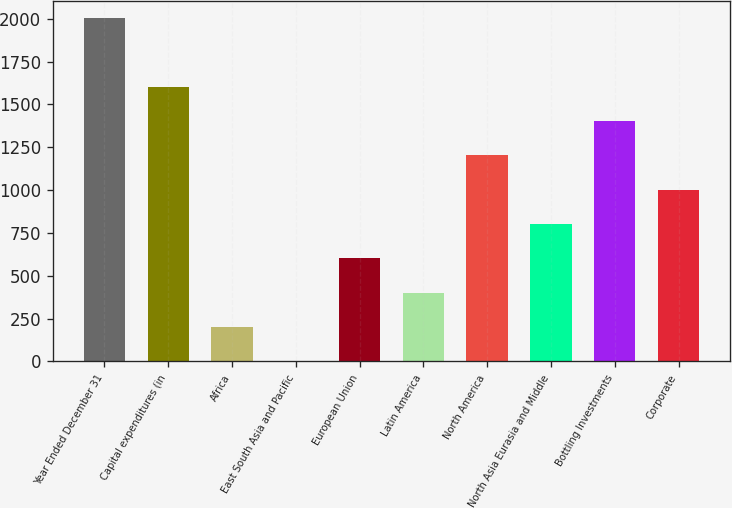Convert chart to OTSL. <chart><loc_0><loc_0><loc_500><loc_500><bar_chart><fcel>Year Ended December 31<fcel>Capital expenditures (in<fcel>Africa<fcel>East South Asia and Pacific<fcel>European Union<fcel>Latin America<fcel>North America<fcel>North Asia Eurasia and Middle<fcel>Bottling Investments<fcel>Corporate<nl><fcel>2004<fcel>1603.38<fcel>201.21<fcel>0.9<fcel>601.83<fcel>401.52<fcel>1202.76<fcel>802.14<fcel>1403.07<fcel>1002.45<nl></chart> 